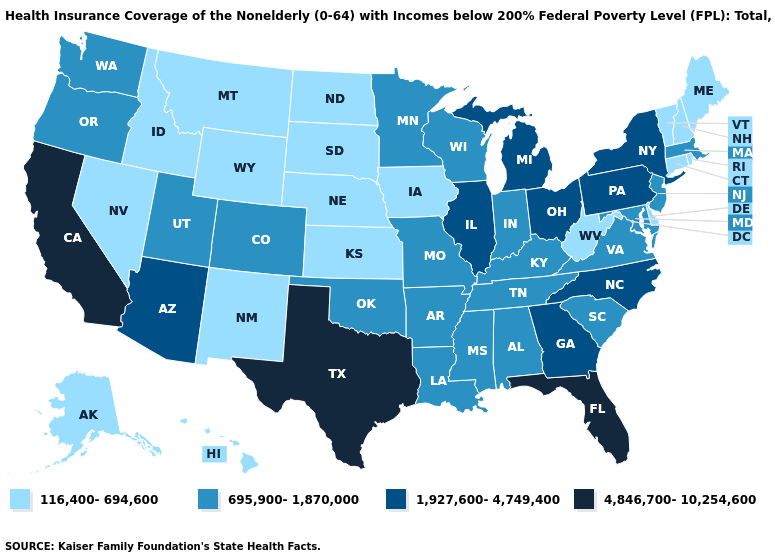What is the value of Delaware?
Write a very short answer. 116,400-694,600. Does Idaho have a higher value than Florida?
Quick response, please. No. Name the states that have a value in the range 116,400-694,600?
Quick response, please. Alaska, Connecticut, Delaware, Hawaii, Idaho, Iowa, Kansas, Maine, Montana, Nebraska, Nevada, New Hampshire, New Mexico, North Dakota, Rhode Island, South Dakota, Vermont, West Virginia, Wyoming. What is the highest value in states that border New Hampshire?
Be succinct. 695,900-1,870,000. What is the highest value in states that border New Hampshire?
Concise answer only. 695,900-1,870,000. Does Rhode Island have the lowest value in the Northeast?
Be succinct. Yes. Does the map have missing data?
Concise answer only. No. Does Massachusetts have a lower value than Virginia?
Short answer required. No. Name the states that have a value in the range 4,846,700-10,254,600?
Concise answer only. California, Florida, Texas. How many symbols are there in the legend?
Concise answer only. 4. Name the states that have a value in the range 1,927,600-4,749,400?
Be succinct. Arizona, Georgia, Illinois, Michigan, New York, North Carolina, Ohio, Pennsylvania. Name the states that have a value in the range 695,900-1,870,000?
Be succinct. Alabama, Arkansas, Colorado, Indiana, Kentucky, Louisiana, Maryland, Massachusetts, Minnesota, Mississippi, Missouri, New Jersey, Oklahoma, Oregon, South Carolina, Tennessee, Utah, Virginia, Washington, Wisconsin. Which states have the lowest value in the USA?
Answer briefly. Alaska, Connecticut, Delaware, Hawaii, Idaho, Iowa, Kansas, Maine, Montana, Nebraska, Nevada, New Hampshire, New Mexico, North Dakota, Rhode Island, South Dakota, Vermont, West Virginia, Wyoming. Among the states that border Missouri , does Oklahoma have the lowest value?
Give a very brief answer. No. Which states have the highest value in the USA?
Quick response, please. California, Florida, Texas. 